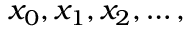Convert formula to latex. <formula><loc_0><loc_0><loc_500><loc_500>x _ { 0 } , x _ { 1 } , x _ { 2 } , \dots ,</formula> 